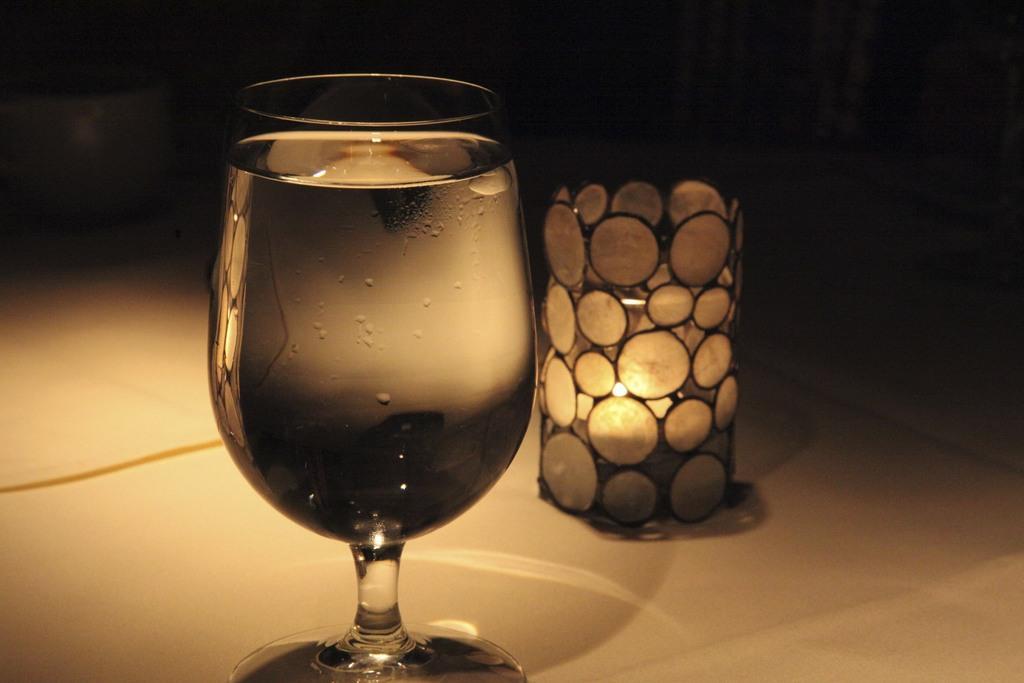How would you summarize this image in a sentence or two? In this image, we can see a wine glass with liquid and candle with holder are placed on the white surface. Background we can see the dark view. On the wine glass, we can see water droplets. 